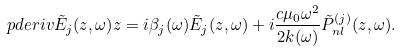Convert formula to latex. <formula><loc_0><loc_0><loc_500><loc_500>\ p d e r i v { \tilde { E } _ { j } ( z , \omega ) } { z } = i \beta _ { j } ( \omega ) \tilde { E } _ { j } ( z , \omega ) + i \frac { c \mu _ { 0 } \omega ^ { 2 } } { 2 k ( \omega ) } \tilde { P } ^ { ( j ) } _ { n l } ( z , \omega ) .</formula> 